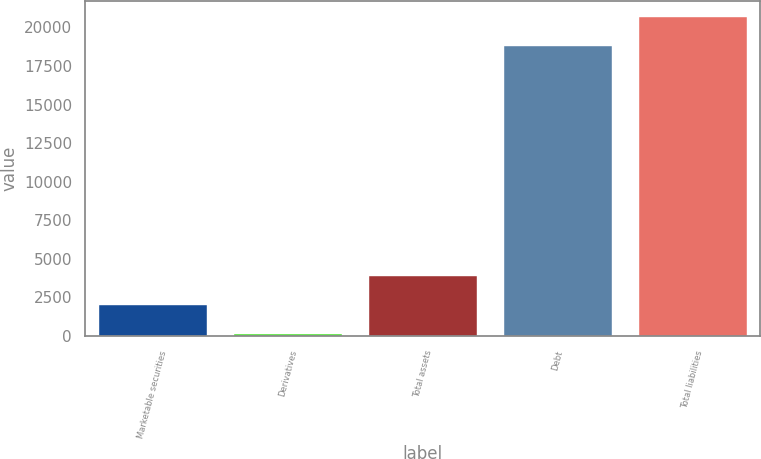<chart> <loc_0><loc_0><loc_500><loc_500><bar_chart><fcel>Marketable securities<fcel>Derivatives<fcel>Total assets<fcel>Debt<fcel>Total liabilities<nl><fcel>2021.7<fcel>119<fcel>3924.4<fcel>18788<fcel>20690.7<nl></chart> 